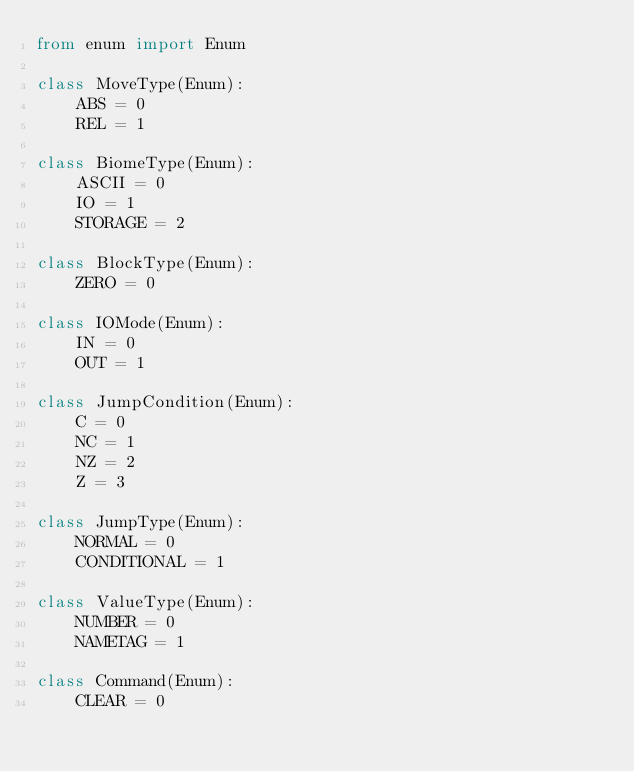<code> <loc_0><loc_0><loc_500><loc_500><_Python_>from enum import Enum

class MoveType(Enum):
    ABS = 0
    REL = 1

class BiomeType(Enum):
    ASCII = 0
    IO = 1
    STORAGE = 2

class BlockType(Enum):
    ZERO = 0

class IOMode(Enum):
    IN = 0
    OUT = 1

class JumpCondition(Enum):
    C = 0
    NC = 1
    NZ = 2
    Z = 3

class JumpType(Enum):
    NORMAL = 0
    CONDITIONAL = 1

class ValueType(Enum):
    NUMBER = 0
    NAMETAG = 1

class Command(Enum):
    CLEAR = 0</code> 